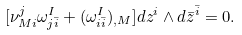Convert formula to latex. <formula><loc_0><loc_0><loc_500><loc_500>[ \nu _ { M i } ^ { j } \omega ^ { I } _ { j \bar { i } } + ( \omega ^ { I } _ { i \bar { i } } ) _ { , M } ] d z ^ { i } \wedge d \bar { z } ^ { \bar { i } } = 0 .</formula> 